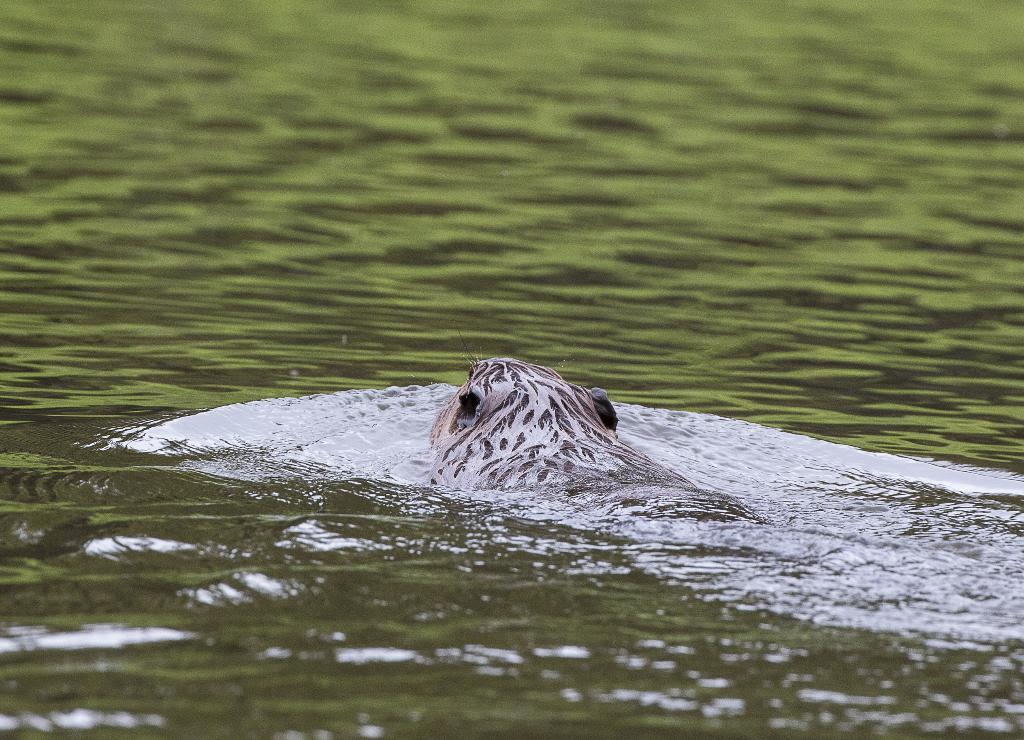What is present in the image that is not solid? There is water visible in the image. What type of living creature can be seen in the image? There is an animal in the image. Reasoning: Let' Let's think step by step in order to produce the conversation. We start by identifying the two main subjects in the image, which are water and an animal. Then, we formulate questions that focus on the characteristics of these subjects, ensuring that each question can be answered definitively with the information given. We avoid yes/no questions and ensure that the language is simple and clear. Absurd Question/Answer: What type of sticks can be seen in the image? There are no sticks present in the image. How many snakes are visible in the image? There is no mention of snakes in the image; only an animal is mentioned. What type of pencil can be seen in the image? There are no pencils present in the image. 